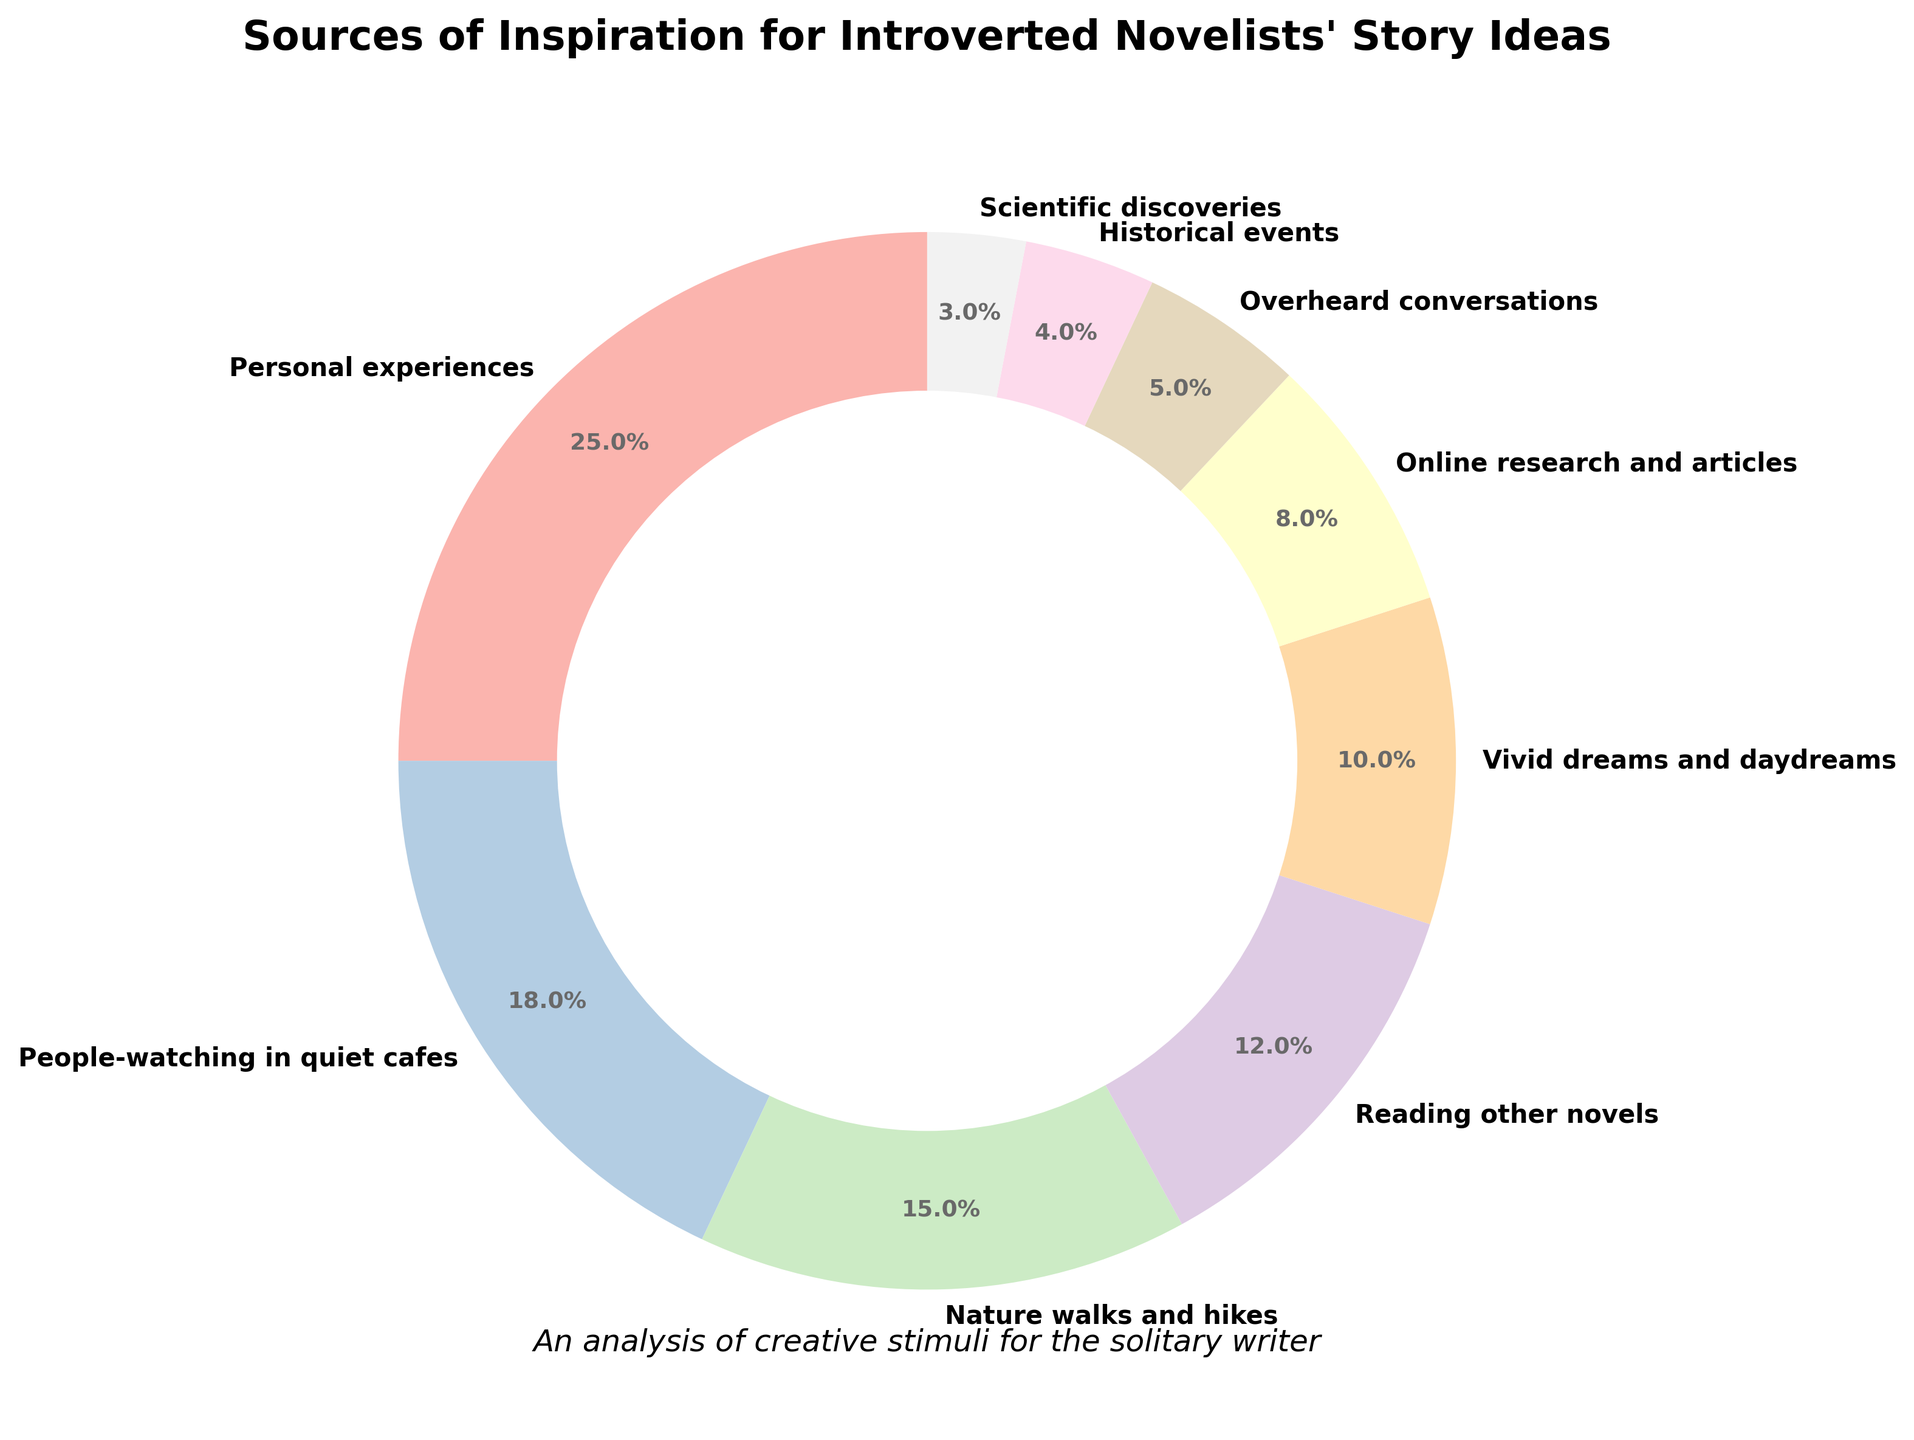Which source of inspiration takes up the largest portion of the pie chart? The largest portion is the one with the highest percentage. By examining the slices, "Personal experiences" occupies the largest segment with 25%.
Answer: Personal experiences How many sources of inspiration have a percentage higher than 10%? By looking at the chart, count all the sources whose percentages are greater than 10%. These are "Personal experiences" (25%), "People-watching in quiet cafes" (18%), "Nature walks and hikes" (15%), and "Reading other novels" (12%). There are 4 such sources.
Answer: 4 What is the combined percentage of "Online research and articles" and "Vivid dreams and daydreams"? Add the percentages for "Online research and articles" (8%) and "Vivid dreams and daydreams" (10%). The total is 8% + 10% = 18%.
Answer: 18% Which source of inspiration is the smallest in the pie chart? By identifying the smallest slice, it is clear that "Scientific discoveries" has the smallest percentage at 3%.
Answer: Scientific discoveries Is "Nature walks and hikes" a more common source of inspiration than "Reading other novels"? Compare the percentages of "Nature walks and hikes" (15%) and "Reading other novels" (12%). Since 15% is greater than 12%, "Nature walks and hikes" is more common.
Answer: Yes What is the difference in percentage between the most and least common sources of inspiration? The most common source has 25% (Personal experiences) and the least common source has 3% (Scientific discoveries). The difference is 25% - 3% = 22%.
Answer: 22% Are there more sources above or below 10%? Count the number of sources with percentages above 10% and below 10%. Above 10%: 4 sources ("Personal experiences," "People-watching in quiet cafes," "Nature walks and hikes," "Reading other novels"); below 10%: 5 sources ("Vivid dreams and daydreams," "Online research and articles," "Overheard conversations," "Historical events," "Scientific discoveries"). Thus, there are more sources below 10%.
Answer: Below What is the average percentage of all sources of inspiration? Add all the percentages and divide by the number of sources. The sum is 25 + 18 + 15 + 12 + 10 + 8 + 5 + 4 + 3 = 100. The average is 100/9 ≈ 11.1%.
Answer: 11.1% How does the percentage of "People-watching in quiet cafes" compare to "Vivid dreams and daydreams"? Compare the two percentages; "People-watching in quiet cafes" has 18%, and "Vivid dreams and daydreams" has 10%. "People-watching in quiet cafes" has a higher percentage.
Answer: People-watching in quiet cafes is higher 